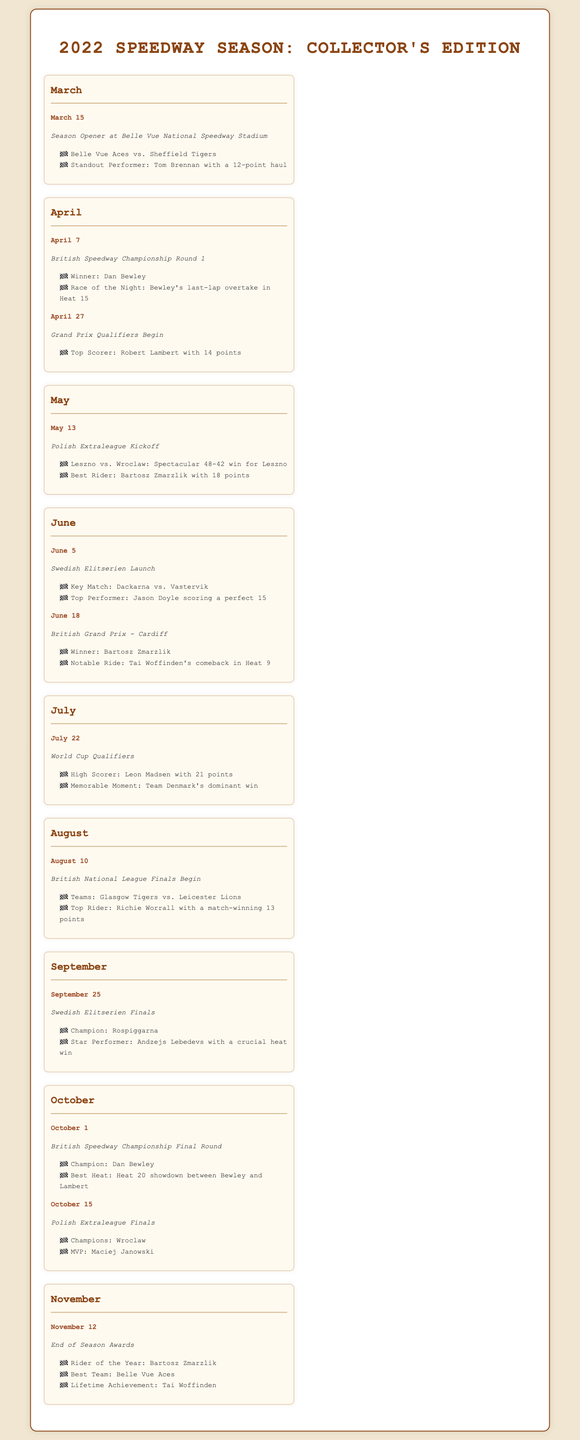What was the Season Opener date? The Season Opener took place on March 15, which is specified in the March section of the timeline.
Answer: March 15 Who was the standout performer in March? Tom Brennan is highlighted as the standout performer in March, as stated in the event description for that month.
Answer: Tom Brennan Which team won the British Speedway Championship Final Round? The champion of the British Speedway Championship Final Round is mentioned in the October section of the document.
Answer: Dan Bewley What was Bartosz Zmarzlik's achievement in the British Grand Prix? Bartosz Zmarzlik's achievement as the winner is detailed in the June section of the document.
Answer: Winner How many points did Leon Madsen score in the World Cup Qualifiers? Leon Madsen is noted as the high scorer with 21 points in the July section of the document.
Answer: 21 points Which event marked the end of the 2022 season? The end of the season is marked by the End of Season Awards event in November as indicated in the timeline.
Answer: End of Season Awards How many points did Bartosz Zmarzlik score as the Best Rider in May? The document notes Bartosz Zmarzlik's total points as recognized for his performance in the Polish Extraleague.
Answer: 18 points What significant moment occurred on October 15? The Polish Extraleague Finals and its champions, which is an important event discussed in the October section of the document, highlights this date.
Answer: Polish Extraleague Finals What was awarded to Tai Woffinden in November? The document awards Tai Woffinden a Lifetime Achievement honor during the End of Season Awards in November.
Answer: Lifetime Achievement 